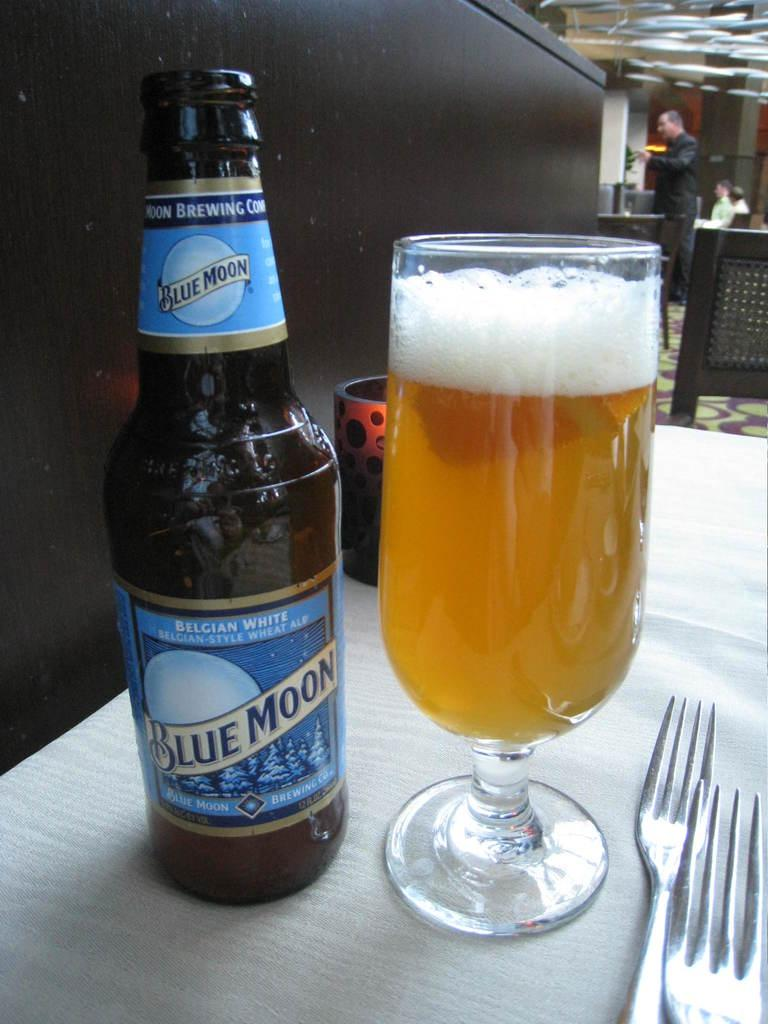<image>
Offer a succinct explanation of the picture presented. A bottle of blue moon alcohol next to beer in a glass. 